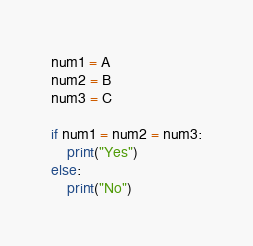<code> <loc_0><loc_0><loc_500><loc_500><_Python_>num1 = A
num2 = B
num3 = C

if num1 = num2 = num3:
    print("Yes")
else:
    print("No")</code> 